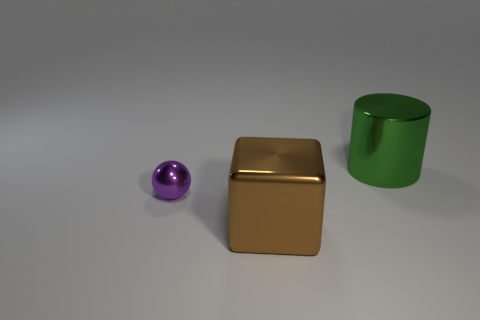Add 2 rubber blocks. How many objects exist? 5 Subtract all cylinders. How many objects are left? 2 Subtract 0 cyan cylinders. How many objects are left? 3 Subtract all large green shiny things. Subtract all large red matte objects. How many objects are left? 2 Add 3 large brown things. How many large brown things are left? 4 Add 1 big brown blocks. How many big brown blocks exist? 2 